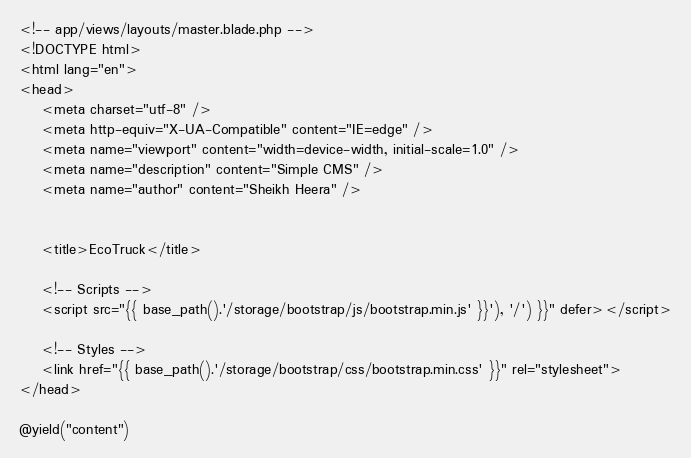<code> <loc_0><loc_0><loc_500><loc_500><_PHP_><!-- app/views/layouts/master.blade.php -->
<!DOCTYPE html>
<html lang="en">
<head>
    <meta charset="utf-8" />
    <meta http-equiv="X-UA-Compatible" content="IE=edge" />
    <meta name="viewport" content="width=device-width, initial-scale=1.0" />
    <meta name="description" content="Simple CMS" />
    <meta name="author" content="Sheikh Heera" />
    

    <title>EcoTruck</title>
    
    <!-- Scripts -->
    <script src="{{ base_path().'/storage/bootstrap/js/bootstrap.min.js' }}'), '/') }}" defer></script>

    <!-- Styles -->
    <link href="{{ base_path().'/storage/bootstrap/css/bootstrap.min.css' }}" rel="stylesheet">
</head>

@yield("content")

</code> 